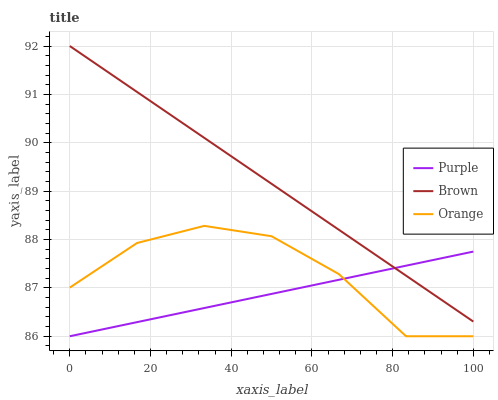Does Purple have the minimum area under the curve?
Answer yes or no. Yes. Does Brown have the maximum area under the curve?
Answer yes or no. Yes. Does Orange have the minimum area under the curve?
Answer yes or no. No. Does Orange have the maximum area under the curve?
Answer yes or no. No. Is Brown the smoothest?
Answer yes or no. Yes. Is Orange the roughest?
Answer yes or no. Yes. Is Orange the smoothest?
Answer yes or no. No. Is Brown the roughest?
Answer yes or no. No. Does Purple have the lowest value?
Answer yes or no. Yes. Does Brown have the lowest value?
Answer yes or no. No. Does Brown have the highest value?
Answer yes or no. Yes. Does Orange have the highest value?
Answer yes or no. No. Is Orange less than Brown?
Answer yes or no. Yes. Is Brown greater than Orange?
Answer yes or no. Yes. Does Purple intersect Brown?
Answer yes or no. Yes. Is Purple less than Brown?
Answer yes or no. No. Is Purple greater than Brown?
Answer yes or no. No. Does Orange intersect Brown?
Answer yes or no. No. 